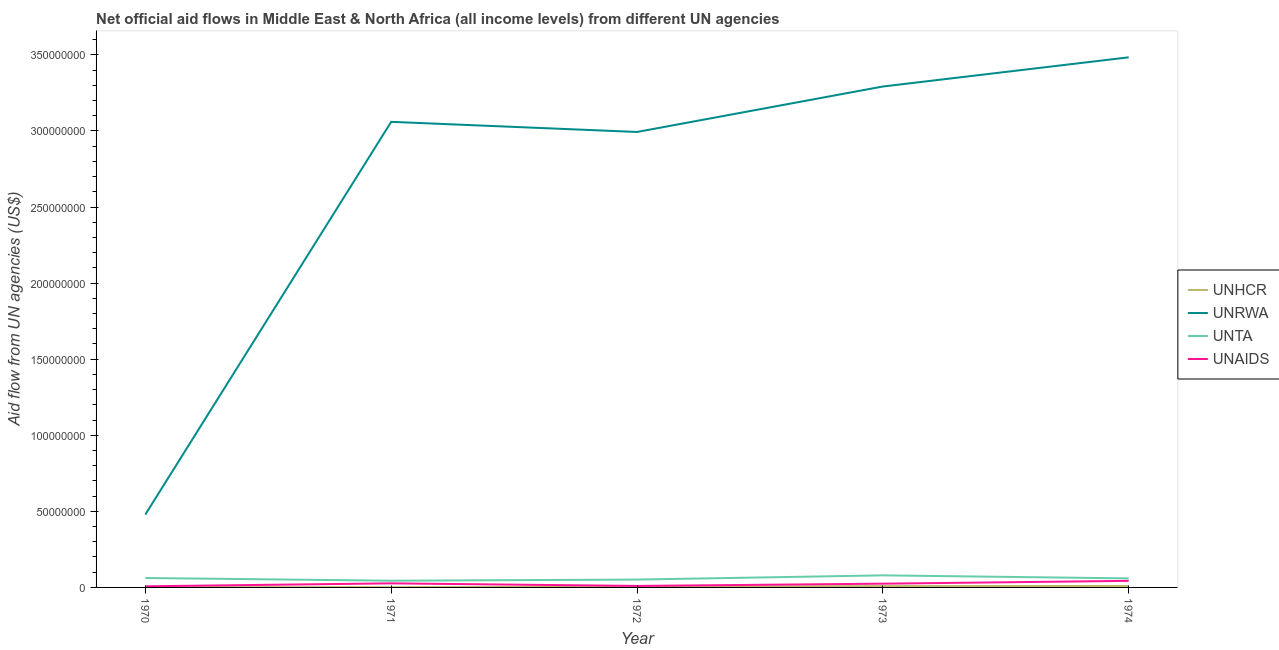How many different coloured lines are there?
Your answer should be compact. 4. What is the amount of aid given by unrwa in 1971?
Ensure brevity in your answer.  3.06e+08. Across all years, what is the maximum amount of aid given by unaids?
Offer a very short reply. 4.32e+06. Across all years, what is the minimum amount of aid given by unta?
Offer a terse response. 4.41e+06. In which year was the amount of aid given by unhcr maximum?
Offer a terse response. 1974. In which year was the amount of aid given by unrwa minimum?
Your answer should be compact. 1970. What is the total amount of aid given by unta in the graph?
Your response must be concise. 2.96e+07. What is the difference between the amount of aid given by unhcr in 1970 and that in 1973?
Make the answer very short. -7.10e+05. What is the difference between the amount of aid given by unhcr in 1973 and the amount of aid given by unta in 1972?
Offer a terse response. -4.28e+06. What is the average amount of aid given by unrwa per year?
Ensure brevity in your answer.  2.66e+08. In the year 1974, what is the difference between the amount of aid given by unta and amount of aid given by unhcr?
Keep it short and to the point. 4.97e+06. In how many years, is the amount of aid given by unaids greater than 250000000 US$?
Give a very brief answer. 0. What is the ratio of the amount of aid given by unrwa in 1973 to that in 1974?
Your response must be concise. 0.94. What is the difference between the highest and the second highest amount of aid given by unta?
Your response must be concise. 1.72e+06. What is the difference between the highest and the lowest amount of aid given by unrwa?
Your response must be concise. 3.00e+08. Is the sum of the amount of aid given by unta in 1970 and 1971 greater than the maximum amount of aid given by unaids across all years?
Ensure brevity in your answer.  Yes. Is the amount of aid given by unrwa strictly greater than the amount of aid given by unta over the years?
Provide a short and direct response. Yes. What is the difference between two consecutive major ticks on the Y-axis?
Offer a very short reply. 5.00e+07. Are the values on the major ticks of Y-axis written in scientific E-notation?
Give a very brief answer. No. Does the graph contain any zero values?
Your response must be concise. No. Where does the legend appear in the graph?
Ensure brevity in your answer.  Center right. How are the legend labels stacked?
Provide a succinct answer. Vertical. What is the title of the graph?
Your answer should be compact. Net official aid flows in Middle East & North Africa (all income levels) from different UN agencies. What is the label or title of the X-axis?
Make the answer very short. Year. What is the label or title of the Y-axis?
Give a very brief answer. Aid flow from UN agencies (US$). What is the Aid flow from UN agencies (US$) in UNHCR in 1970?
Make the answer very short. 1.70e+05. What is the Aid flow from UN agencies (US$) of UNRWA in 1970?
Provide a succinct answer. 4.79e+07. What is the Aid flow from UN agencies (US$) in UNTA in 1970?
Make the answer very short. 6.21e+06. What is the Aid flow from UN agencies (US$) in UNAIDS in 1970?
Make the answer very short. 7.40e+05. What is the Aid flow from UN agencies (US$) in UNHCR in 1971?
Your answer should be very brief. 1.40e+05. What is the Aid flow from UN agencies (US$) of UNRWA in 1971?
Offer a terse response. 3.06e+08. What is the Aid flow from UN agencies (US$) of UNTA in 1971?
Your response must be concise. 4.41e+06. What is the Aid flow from UN agencies (US$) in UNAIDS in 1971?
Provide a succinct answer. 2.68e+06. What is the Aid flow from UN agencies (US$) in UNRWA in 1972?
Offer a very short reply. 2.99e+08. What is the Aid flow from UN agencies (US$) of UNTA in 1972?
Offer a terse response. 5.16e+06. What is the Aid flow from UN agencies (US$) of UNAIDS in 1972?
Your response must be concise. 9.80e+05. What is the Aid flow from UN agencies (US$) in UNHCR in 1973?
Provide a succinct answer. 8.80e+05. What is the Aid flow from UN agencies (US$) in UNRWA in 1973?
Offer a very short reply. 3.29e+08. What is the Aid flow from UN agencies (US$) in UNTA in 1973?
Offer a very short reply. 7.93e+06. What is the Aid flow from UN agencies (US$) in UNAIDS in 1973?
Offer a very short reply. 2.47e+06. What is the Aid flow from UN agencies (US$) in UNHCR in 1974?
Keep it short and to the point. 9.70e+05. What is the Aid flow from UN agencies (US$) in UNRWA in 1974?
Your answer should be compact. 3.48e+08. What is the Aid flow from UN agencies (US$) of UNTA in 1974?
Ensure brevity in your answer.  5.94e+06. What is the Aid flow from UN agencies (US$) in UNAIDS in 1974?
Keep it short and to the point. 4.32e+06. Across all years, what is the maximum Aid flow from UN agencies (US$) of UNHCR?
Provide a short and direct response. 9.70e+05. Across all years, what is the maximum Aid flow from UN agencies (US$) in UNRWA?
Provide a short and direct response. 3.48e+08. Across all years, what is the maximum Aid flow from UN agencies (US$) of UNTA?
Your response must be concise. 7.93e+06. Across all years, what is the maximum Aid flow from UN agencies (US$) of UNAIDS?
Provide a short and direct response. 4.32e+06. Across all years, what is the minimum Aid flow from UN agencies (US$) in UNRWA?
Offer a very short reply. 4.79e+07. Across all years, what is the minimum Aid flow from UN agencies (US$) of UNTA?
Your response must be concise. 4.41e+06. Across all years, what is the minimum Aid flow from UN agencies (US$) in UNAIDS?
Your answer should be very brief. 7.40e+05. What is the total Aid flow from UN agencies (US$) in UNHCR in the graph?
Your answer should be very brief. 2.62e+06. What is the total Aid flow from UN agencies (US$) of UNRWA in the graph?
Ensure brevity in your answer.  1.33e+09. What is the total Aid flow from UN agencies (US$) in UNTA in the graph?
Offer a terse response. 2.96e+07. What is the total Aid flow from UN agencies (US$) of UNAIDS in the graph?
Ensure brevity in your answer.  1.12e+07. What is the difference between the Aid flow from UN agencies (US$) in UNRWA in 1970 and that in 1971?
Offer a very short reply. -2.58e+08. What is the difference between the Aid flow from UN agencies (US$) in UNTA in 1970 and that in 1971?
Ensure brevity in your answer.  1.80e+06. What is the difference between the Aid flow from UN agencies (US$) in UNAIDS in 1970 and that in 1971?
Provide a short and direct response. -1.94e+06. What is the difference between the Aid flow from UN agencies (US$) of UNHCR in 1970 and that in 1972?
Offer a terse response. -2.90e+05. What is the difference between the Aid flow from UN agencies (US$) in UNRWA in 1970 and that in 1972?
Ensure brevity in your answer.  -2.51e+08. What is the difference between the Aid flow from UN agencies (US$) in UNTA in 1970 and that in 1972?
Ensure brevity in your answer.  1.05e+06. What is the difference between the Aid flow from UN agencies (US$) in UNHCR in 1970 and that in 1973?
Make the answer very short. -7.10e+05. What is the difference between the Aid flow from UN agencies (US$) of UNRWA in 1970 and that in 1973?
Provide a short and direct response. -2.81e+08. What is the difference between the Aid flow from UN agencies (US$) of UNTA in 1970 and that in 1973?
Make the answer very short. -1.72e+06. What is the difference between the Aid flow from UN agencies (US$) of UNAIDS in 1970 and that in 1973?
Your response must be concise. -1.73e+06. What is the difference between the Aid flow from UN agencies (US$) of UNHCR in 1970 and that in 1974?
Offer a very short reply. -8.00e+05. What is the difference between the Aid flow from UN agencies (US$) of UNRWA in 1970 and that in 1974?
Offer a terse response. -3.00e+08. What is the difference between the Aid flow from UN agencies (US$) of UNTA in 1970 and that in 1974?
Ensure brevity in your answer.  2.70e+05. What is the difference between the Aid flow from UN agencies (US$) of UNAIDS in 1970 and that in 1974?
Your response must be concise. -3.58e+06. What is the difference between the Aid flow from UN agencies (US$) of UNHCR in 1971 and that in 1972?
Ensure brevity in your answer.  -3.20e+05. What is the difference between the Aid flow from UN agencies (US$) of UNRWA in 1971 and that in 1972?
Your response must be concise. 6.65e+06. What is the difference between the Aid flow from UN agencies (US$) of UNTA in 1971 and that in 1972?
Offer a very short reply. -7.50e+05. What is the difference between the Aid flow from UN agencies (US$) of UNAIDS in 1971 and that in 1972?
Ensure brevity in your answer.  1.70e+06. What is the difference between the Aid flow from UN agencies (US$) of UNHCR in 1971 and that in 1973?
Your answer should be very brief. -7.40e+05. What is the difference between the Aid flow from UN agencies (US$) of UNRWA in 1971 and that in 1973?
Provide a short and direct response. -2.32e+07. What is the difference between the Aid flow from UN agencies (US$) in UNTA in 1971 and that in 1973?
Your response must be concise. -3.52e+06. What is the difference between the Aid flow from UN agencies (US$) in UNHCR in 1971 and that in 1974?
Ensure brevity in your answer.  -8.30e+05. What is the difference between the Aid flow from UN agencies (US$) of UNRWA in 1971 and that in 1974?
Offer a terse response. -4.24e+07. What is the difference between the Aid flow from UN agencies (US$) in UNTA in 1971 and that in 1974?
Your answer should be compact. -1.53e+06. What is the difference between the Aid flow from UN agencies (US$) in UNAIDS in 1971 and that in 1974?
Offer a terse response. -1.64e+06. What is the difference between the Aid flow from UN agencies (US$) of UNHCR in 1972 and that in 1973?
Keep it short and to the point. -4.20e+05. What is the difference between the Aid flow from UN agencies (US$) in UNRWA in 1972 and that in 1973?
Provide a short and direct response. -2.99e+07. What is the difference between the Aid flow from UN agencies (US$) in UNTA in 1972 and that in 1973?
Give a very brief answer. -2.77e+06. What is the difference between the Aid flow from UN agencies (US$) in UNAIDS in 1972 and that in 1973?
Offer a very short reply. -1.49e+06. What is the difference between the Aid flow from UN agencies (US$) in UNHCR in 1972 and that in 1974?
Provide a short and direct response. -5.10e+05. What is the difference between the Aid flow from UN agencies (US$) in UNRWA in 1972 and that in 1974?
Provide a short and direct response. -4.91e+07. What is the difference between the Aid flow from UN agencies (US$) in UNTA in 1972 and that in 1974?
Give a very brief answer. -7.80e+05. What is the difference between the Aid flow from UN agencies (US$) of UNAIDS in 1972 and that in 1974?
Ensure brevity in your answer.  -3.34e+06. What is the difference between the Aid flow from UN agencies (US$) of UNRWA in 1973 and that in 1974?
Give a very brief answer. -1.92e+07. What is the difference between the Aid flow from UN agencies (US$) of UNTA in 1973 and that in 1974?
Your answer should be very brief. 1.99e+06. What is the difference between the Aid flow from UN agencies (US$) in UNAIDS in 1973 and that in 1974?
Keep it short and to the point. -1.85e+06. What is the difference between the Aid flow from UN agencies (US$) of UNHCR in 1970 and the Aid flow from UN agencies (US$) of UNRWA in 1971?
Offer a terse response. -3.06e+08. What is the difference between the Aid flow from UN agencies (US$) of UNHCR in 1970 and the Aid flow from UN agencies (US$) of UNTA in 1971?
Your response must be concise. -4.24e+06. What is the difference between the Aid flow from UN agencies (US$) of UNHCR in 1970 and the Aid flow from UN agencies (US$) of UNAIDS in 1971?
Your answer should be very brief. -2.51e+06. What is the difference between the Aid flow from UN agencies (US$) in UNRWA in 1970 and the Aid flow from UN agencies (US$) in UNTA in 1971?
Ensure brevity in your answer.  4.35e+07. What is the difference between the Aid flow from UN agencies (US$) in UNRWA in 1970 and the Aid flow from UN agencies (US$) in UNAIDS in 1971?
Ensure brevity in your answer.  4.52e+07. What is the difference between the Aid flow from UN agencies (US$) in UNTA in 1970 and the Aid flow from UN agencies (US$) in UNAIDS in 1971?
Offer a very short reply. 3.53e+06. What is the difference between the Aid flow from UN agencies (US$) in UNHCR in 1970 and the Aid flow from UN agencies (US$) in UNRWA in 1972?
Make the answer very short. -2.99e+08. What is the difference between the Aid flow from UN agencies (US$) in UNHCR in 1970 and the Aid flow from UN agencies (US$) in UNTA in 1972?
Keep it short and to the point. -4.99e+06. What is the difference between the Aid flow from UN agencies (US$) in UNHCR in 1970 and the Aid flow from UN agencies (US$) in UNAIDS in 1972?
Your answer should be compact. -8.10e+05. What is the difference between the Aid flow from UN agencies (US$) in UNRWA in 1970 and the Aid flow from UN agencies (US$) in UNTA in 1972?
Offer a terse response. 4.28e+07. What is the difference between the Aid flow from UN agencies (US$) of UNRWA in 1970 and the Aid flow from UN agencies (US$) of UNAIDS in 1972?
Provide a succinct answer. 4.70e+07. What is the difference between the Aid flow from UN agencies (US$) of UNTA in 1970 and the Aid flow from UN agencies (US$) of UNAIDS in 1972?
Ensure brevity in your answer.  5.23e+06. What is the difference between the Aid flow from UN agencies (US$) in UNHCR in 1970 and the Aid flow from UN agencies (US$) in UNRWA in 1973?
Offer a very short reply. -3.29e+08. What is the difference between the Aid flow from UN agencies (US$) in UNHCR in 1970 and the Aid flow from UN agencies (US$) in UNTA in 1973?
Your answer should be very brief. -7.76e+06. What is the difference between the Aid flow from UN agencies (US$) in UNHCR in 1970 and the Aid flow from UN agencies (US$) in UNAIDS in 1973?
Offer a very short reply. -2.30e+06. What is the difference between the Aid flow from UN agencies (US$) in UNRWA in 1970 and the Aid flow from UN agencies (US$) in UNTA in 1973?
Ensure brevity in your answer.  4.00e+07. What is the difference between the Aid flow from UN agencies (US$) of UNRWA in 1970 and the Aid flow from UN agencies (US$) of UNAIDS in 1973?
Ensure brevity in your answer.  4.55e+07. What is the difference between the Aid flow from UN agencies (US$) of UNTA in 1970 and the Aid flow from UN agencies (US$) of UNAIDS in 1973?
Offer a very short reply. 3.74e+06. What is the difference between the Aid flow from UN agencies (US$) of UNHCR in 1970 and the Aid flow from UN agencies (US$) of UNRWA in 1974?
Offer a very short reply. -3.48e+08. What is the difference between the Aid flow from UN agencies (US$) of UNHCR in 1970 and the Aid flow from UN agencies (US$) of UNTA in 1974?
Make the answer very short. -5.77e+06. What is the difference between the Aid flow from UN agencies (US$) of UNHCR in 1970 and the Aid flow from UN agencies (US$) of UNAIDS in 1974?
Your answer should be very brief. -4.15e+06. What is the difference between the Aid flow from UN agencies (US$) in UNRWA in 1970 and the Aid flow from UN agencies (US$) in UNTA in 1974?
Make the answer very short. 4.20e+07. What is the difference between the Aid flow from UN agencies (US$) in UNRWA in 1970 and the Aid flow from UN agencies (US$) in UNAIDS in 1974?
Your response must be concise. 4.36e+07. What is the difference between the Aid flow from UN agencies (US$) of UNTA in 1970 and the Aid flow from UN agencies (US$) of UNAIDS in 1974?
Your answer should be very brief. 1.89e+06. What is the difference between the Aid flow from UN agencies (US$) of UNHCR in 1971 and the Aid flow from UN agencies (US$) of UNRWA in 1972?
Provide a succinct answer. -2.99e+08. What is the difference between the Aid flow from UN agencies (US$) in UNHCR in 1971 and the Aid flow from UN agencies (US$) in UNTA in 1972?
Keep it short and to the point. -5.02e+06. What is the difference between the Aid flow from UN agencies (US$) of UNHCR in 1971 and the Aid flow from UN agencies (US$) of UNAIDS in 1972?
Make the answer very short. -8.40e+05. What is the difference between the Aid flow from UN agencies (US$) in UNRWA in 1971 and the Aid flow from UN agencies (US$) in UNTA in 1972?
Offer a very short reply. 3.01e+08. What is the difference between the Aid flow from UN agencies (US$) of UNRWA in 1971 and the Aid flow from UN agencies (US$) of UNAIDS in 1972?
Offer a terse response. 3.05e+08. What is the difference between the Aid flow from UN agencies (US$) of UNTA in 1971 and the Aid flow from UN agencies (US$) of UNAIDS in 1972?
Give a very brief answer. 3.43e+06. What is the difference between the Aid flow from UN agencies (US$) in UNHCR in 1971 and the Aid flow from UN agencies (US$) in UNRWA in 1973?
Provide a succinct answer. -3.29e+08. What is the difference between the Aid flow from UN agencies (US$) of UNHCR in 1971 and the Aid flow from UN agencies (US$) of UNTA in 1973?
Make the answer very short. -7.79e+06. What is the difference between the Aid flow from UN agencies (US$) of UNHCR in 1971 and the Aid flow from UN agencies (US$) of UNAIDS in 1973?
Make the answer very short. -2.33e+06. What is the difference between the Aid flow from UN agencies (US$) of UNRWA in 1971 and the Aid flow from UN agencies (US$) of UNTA in 1973?
Offer a very short reply. 2.98e+08. What is the difference between the Aid flow from UN agencies (US$) in UNRWA in 1971 and the Aid flow from UN agencies (US$) in UNAIDS in 1973?
Your answer should be compact. 3.04e+08. What is the difference between the Aid flow from UN agencies (US$) in UNTA in 1971 and the Aid flow from UN agencies (US$) in UNAIDS in 1973?
Give a very brief answer. 1.94e+06. What is the difference between the Aid flow from UN agencies (US$) in UNHCR in 1971 and the Aid flow from UN agencies (US$) in UNRWA in 1974?
Offer a very short reply. -3.48e+08. What is the difference between the Aid flow from UN agencies (US$) of UNHCR in 1971 and the Aid flow from UN agencies (US$) of UNTA in 1974?
Your response must be concise. -5.80e+06. What is the difference between the Aid flow from UN agencies (US$) in UNHCR in 1971 and the Aid flow from UN agencies (US$) in UNAIDS in 1974?
Give a very brief answer. -4.18e+06. What is the difference between the Aid flow from UN agencies (US$) of UNRWA in 1971 and the Aid flow from UN agencies (US$) of UNTA in 1974?
Ensure brevity in your answer.  3.00e+08. What is the difference between the Aid flow from UN agencies (US$) in UNRWA in 1971 and the Aid flow from UN agencies (US$) in UNAIDS in 1974?
Offer a very short reply. 3.02e+08. What is the difference between the Aid flow from UN agencies (US$) of UNHCR in 1972 and the Aid flow from UN agencies (US$) of UNRWA in 1973?
Your answer should be very brief. -3.29e+08. What is the difference between the Aid flow from UN agencies (US$) of UNHCR in 1972 and the Aid flow from UN agencies (US$) of UNTA in 1973?
Your answer should be very brief. -7.47e+06. What is the difference between the Aid flow from UN agencies (US$) in UNHCR in 1972 and the Aid flow from UN agencies (US$) in UNAIDS in 1973?
Provide a succinct answer. -2.01e+06. What is the difference between the Aid flow from UN agencies (US$) in UNRWA in 1972 and the Aid flow from UN agencies (US$) in UNTA in 1973?
Keep it short and to the point. 2.91e+08. What is the difference between the Aid flow from UN agencies (US$) of UNRWA in 1972 and the Aid flow from UN agencies (US$) of UNAIDS in 1973?
Your response must be concise. 2.97e+08. What is the difference between the Aid flow from UN agencies (US$) of UNTA in 1972 and the Aid flow from UN agencies (US$) of UNAIDS in 1973?
Keep it short and to the point. 2.69e+06. What is the difference between the Aid flow from UN agencies (US$) in UNHCR in 1972 and the Aid flow from UN agencies (US$) in UNRWA in 1974?
Give a very brief answer. -3.48e+08. What is the difference between the Aid flow from UN agencies (US$) of UNHCR in 1972 and the Aid flow from UN agencies (US$) of UNTA in 1974?
Provide a succinct answer. -5.48e+06. What is the difference between the Aid flow from UN agencies (US$) in UNHCR in 1972 and the Aid flow from UN agencies (US$) in UNAIDS in 1974?
Your answer should be very brief. -3.86e+06. What is the difference between the Aid flow from UN agencies (US$) of UNRWA in 1972 and the Aid flow from UN agencies (US$) of UNTA in 1974?
Give a very brief answer. 2.93e+08. What is the difference between the Aid flow from UN agencies (US$) in UNRWA in 1972 and the Aid flow from UN agencies (US$) in UNAIDS in 1974?
Offer a terse response. 2.95e+08. What is the difference between the Aid flow from UN agencies (US$) of UNTA in 1972 and the Aid flow from UN agencies (US$) of UNAIDS in 1974?
Make the answer very short. 8.40e+05. What is the difference between the Aid flow from UN agencies (US$) of UNHCR in 1973 and the Aid flow from UN agencies (US$) of UNRWA in 1974?
Keep it short and to the point. -3.48e+08. What is the difference between the Aid flow from UN agencies (US$) in UNHCR in 1973 and the Aid flow from UN agencies (US$) in UNTA in 1974?
Give a very brief answer. -5.06e+06. What is the difference between the Aid flow from UN agencies (US$) in UNHCR in 1973 and the Aid flow from UN agencies (US$) in UNAIDS in 1974?
Keep it short and to the point. -3.44e+06. What is the difference between the Aid flow from UN agencies (US$) of UNRWA in 1973 and the Aid flow from UN agencies (US$) of UNTA in 1974?
Ensure brevity in your answer.  3.23e+08. What is the difference between the Aid flow from UN agencies (US$) in UNRWA in 1973 and the Aid flow from UN agencies (US$) in UNAIDS in 1974?
Make the answer very short. 3.25e+08. What is the difference between the Aid flow from UN agencies (US$) of UNTA in 1973 and the Aid flow from UN agencies (US$) of UNAIDS in 1974?
Your answer should be very brief. 3.61e+06. What is the average Aid flow from UN agencies (US$) in UNHCR per year?
Your answer should be compact. 5.24e+05. What is the average Aid flow from UN agencies (US$) in UNRWA per year?
Keep it short and to the point. 2.66e+08. What is the average Aid flow from UN agencies (US$) in UNTA per year?
Your response must be concise. 5.93e+06. What is the average Aid flow from UN agencies (US$) of UNAIDS per year?
Provide a succinct answer. 2.24e+06. In the year 1970, what is the difference between the Aid flow from UN agencies (US$) in UNHCR and Aid flow from UN agencies (US$) in UNRWA?
Provide a short and direct response. -4.78e+07. In the year 1970, what is the difference between the Aid flow from UN agencies (US$) of UNHCR and Aid flow from UN agencies (US$) of UNTA?
Make the answer very short. -6.04e+06. In the year 1970, what is the difference between the Aid flow from UN agencies (US$) of UNHCR and Aid flow from UN agencies (US$) of UNAIDS?
Provide a short and direct response. -5.70e+05. In the year 1970, what is the difference between the Aid flow from UN agencies (US$) of UNRWA and Aid flow from UN agencies (US$) of UNTA?
Keep it short and to the point. 4.17e+07. In the year 1970, what is the difference between the Aid flow from UN agencies (US$) in UNRWA and Aid flow from UN agencies (US$) in UNAIDS?
Make the answer very short. 4.72e+07. In the year 1970, what is the difference between the Aid flow from UN agencies (US$) in UNTA and Aid flow from UN agencies (US$) in UNAIDS?
Give a very brief answer. 5.47e+06. In the year 1971, what is the difference between the Aid flow from UN agencies (US$) in UNHCR and Aid flow from UN agencies (US$) in UNRWA?
Ensure brevity in your answer.  -3.06e+08. In the year 1971, what is the difference between the Aid flow from UN agencies (US$) of UNHCR and Aid flow from UN agencies (US$) of UNTA?
Offer a terse response. -4.27e+06. In the year 1971, what is the difference between the Aid flow from UN agencies (US$) of UNHCR and Aid flow from UN agencies (US$) of UNAIDS?
Ensure brevity in your answer.  -2.54e+06. In the year 1971, what is the difference between the Aid flow from UN agencies (US$) of UNRWA and Aid flow from UN agencies (US$) of UNTA?
Make the answer very short. 3.02e+08. In the year 1971, what is the difference between the Aid flow from UN agencies (US$) of UNRWA and Aid flow from UN agencies (US$) of UNAIDS?
Your response must be concise. 3.03e+08. In the year 1971, what is the difference between the Aid flow from UN agencies (US$) of UNTA and Aid flow from UN agencies (US$) of UNAIDS?
Your answer should be compact. 1.73e+06. In the year 1972, what is the difference between the Aid flow from UN agencies (US$) of UNHCR and Aid flow from UN agencies (US$) of UNRWA?
Offer a very short reply. -2.99e+08. In the year 1972, what is the difference between the Aid flow from UN agencies (US$) of UNHCR and Aid flow from UN agencies (US$) of UNTA?
Ensure brevity in your answer.  -4.70e+06. In the year 1972, what is the difference between the Aid flow from UN agencies (US$) in UNHCR and Aid flow from UN agencies (US$) in UNAIDS?
Your answer should be compact. -5.20e+05. In the year 1972, what is the difference between the Aid flow from UN agencies (US$) in UNRWA and Aid flow from UN agencies (US$) in UNTA?
Ensure brevity in your answer.  2.94e+08. In the year 1972, what is the difference between the Aid flow from UN agencies (US$) in UNRWA and Aid flow from UN agencies (US$) in UNAIDS?
Your answer should be compact. 2.98e+08. In the year 1972, what is the difference between the Aid flow from UN agencies (US$) of UNTA and Aid flow from UN agencies (US$) of UNAIDS?
Provide a short and direct response. 4.18e+06. In the year 1973, what is the difference between the Aid flow from UN agencies (US$) in UNHCR and Aid flow from UN agencies (US$) in UNRWA?
Provide a short and direct response. -3.28e+08. In the year 1973, what is the difference between the Aid flow from UN agencies (US$) of UNHCR and Aid flow from UN agencies (US$) of UNTA?
Your answer should be very brief. -7.05e+06. In the year 1973, what is the difference between the Aid flow from UN agencies (US$) in UNHCR and Aid flow from UN agencies (US$) in UNAIDS?
Offer a terse response. -1.59e+06. In the year 1973, what is the difference between the Aid flow from UN agencies (US$) in UNRWA and Aid flow from UN agencies (US$) in UNTA?
Offer a very short reply. 3.21e+08. In the year 1973, what is the difference between the Aid flow from UN agencies (US$) in UNRWA and Aid flow from UN agencies (US$) in UNAIDS?
Provide a short and direct response. 3.27e+08. In the year 1973, what is the difference between the Aid flow from UN agencies (US$) of UNTA and Aid flow from UN agencies (US$) of UNAIDS?
Provide a succinct answer. 5.46e+06. In the year 1974, what is the difference between the Aid flow from UN agencies (US$) of UNHCR and Aid flow from UN agencies (US$) of UNRWA?
Give a very brief answer. -3.47e+08. In the year 1974, what is the difference between the Aid flow from UN agencies (US$) of UNHCR and Aid flow from UN agencies (US$) of UNTA?
Your answer should be compact. -4.97e+06. In the year 1974, what is the difference between the Aid flow from UN agencies (US$) of UNHCR and Aid flow from UN agencies (US$) of UNAIDS?
Ensure brevity in your answer.  -3.35e+06. In the year 1974, what is the difference between the Aid flow from UN agencies (US$) in UNRWA and Aid flow from UN agencies (US$) in UNTA?
Your answer should be very brief. 3.42e+08. In the year 1974, what is the difference between the Aid flow from UN agencies (US$) of UNRWA and Aid flow from UN agencies (US$) of UNAIDS?
Offer a terse response. 3.44e+08. In the year 1974, what is the difference between the Aid flow from UN agencies (US$) of UNTA and Aid flow from UN agencies (US$) of UNAIDS?
Your answer should be very brief. 1.62e+06. What is the ratio of the Aid flow from UN agencies (US$) of UNHCR in 1970 to that in 1971?
Ensure brevity in your answer.  1.21. What is the ratio of the Aid flow from UN agencies (US$) of UNRWA in 1970 to that in 1971?
Your answer should be compact. 0.16. What is the ratio of the Aid flow from UN agencies (US$) in UNTA in 1970 to that in 1971?
Offer a terse response. 1.41. What is the ratio of the Aid flow from UN agencies (US$) of UNAIDS in 1970 to that in 1971?
Offer a terse response. 0.28. What is the ratio of the Aid flow from UN agencies (US$) in UNHCR in 1970 to that in 1972?
Offer a very short reply. 0.37. What is the ratio of the Aid flow from UN agencies (US$) in UNRWA in 1970 to that in 1972?
Offer a terse response. 0.16. What is the ratio of the Aid flow from UN agencies (US$) in UNTA in 1970 to that in 1972?
Provide a succinct answer. 1.2. What is the ratio of the Aid flow from UN agencies (US$) in UNAIDS in 1970 to that in 1972?
Make the answer very short. 0.76. What is the ratio of the Aid flow from UN agencies (US$) of UNHCR in 1970 to that in 1973?
Your answer should be very brief. 0.19. What is the ratio of the Aid flow from UN agencies (US$) of UNRWA in 1970 to that in 1973?
Offer a very short reply. 0.15. What is the ratio of the Aid flow from UN agencies (US$) of UNTA in 1970 to that in 1973?
Provide a short and direct response. 0.78. What is the ratio of the Aid flow from UN agencies (US$) of UNAIDS in 1970 to that in 1973?
Your response must be concise. 0.3. What is the ratio of the Aid flow from UN agencies (US$) in UNHCR in 1970 to that in 1974?
Provide a short and direct response. 0.18. What is the ratio of the Aid flow from UN agencies (US$) of UNRWA in 1970 to that in 1974?
Provide a succinct answer. 0.14. What is the ratio of the Aid flow from UN agencies (US$) of UNTA in 1970 to that in 1974?
Offer a very short reply. 1.05. What is the ratio of the Aid flow from UN agencies (US$) in UNAIDS in 1970 to that in 1974?
Offer a very short reply. 0.17. What is the ratio of the Aid flow from UN agencies (US$) of UNHCR in 1971 to that in 1972?
Offer a very short reply. 0.3. What is the ratio of the Aid flow from UN agencies (US$) in UNRWA in 1971 to that in 1972?
Offer a very short reply. 1.02. What is the ratio of the Aid flow from UN agencies (US$) in UNTA in 1971 to that in 1972?
Keep it short and to the point. 0.85. What is the ratio of the Aid flow from UN agencies (US$) of UNAIDS in 1971 to that in 1972?
Offer a very short reply. 2.73. What is the ratio of the Aid flow from UN agencies (US$) of UNHCR in 1971 to that in 1973?
Offer a terse response. 0.16. What is the ratio of the Aid flow from UN agencies (US$) of UNRWA in 1971 to that in 1973?
Offer a terse response. 0.93. What is the ratio of the Aid flow from UN agencies (US$) in UNTA in 1971 to that in 1973?
Keep it short and to the point. 0.56. What is the ratio of the Aid flow from UN agencies (US$) in UNAIDS in 1971 to that in 1973?
Your answer should be very brief. 1.08. What is the ratio of the Aid flow from UN agencies (US$) in UNHCR in 1971 to that in 1974?
Offer a terse response. 0.14. What is the ratio of the Aid flow from UN agencies (US$) in UNRWA in 1971 to that in 1974?
Offer a terse response. 0.88. What is the ratio of the Aid flow from UN agencies (US$) of UNTA in 1971 to that in 1974?
Ensure brevity in your answer.  0.74. What is the ratio of the Aid flow from UN agencies (US$) in UNAIDS in 1971 to that in 1974?
Give a very brief answer. 0.62. What is the ratio of the Aid flow from UN agencies (US$) in UNHCR in 1972 to that in 1973?
Your answer should be compact. 0.52. What is the ratio of the Aid flow from UN agencies (US$) of UNRWA in 1972 to that in 1973?
Offer a very short reply. 0.91. What is the ratio of the Aid flow from UN agencies (US$) of UNTA in 1972 to that in 1973?
Ensure brevity in your answer.  0.65. What is the ratio of the Aid flow from UN agencies (US$) of UNAIDS in 1972 to that in 1973?
Your response must be concise. 0.4. What is the ratio of the Aid flow from UN agencies (US$) in UNHCR in 1972 to that in 1974?
Make the answer very short. 0.47. What is the ratio of the Aid flow from UN agencies (US$) of UNRWA in 1972 to that in 1974?
Ensure brevity in your answer.  0.86. What is the ratio of the Aid flow from UN agencies (US$) of UNTA in 1972 to that in 1974?
Make the answer very short. 0.87. What is the ratio of the Aid flow from UN agencies (US$) of UNAIDS in 1972 to that in 1974?
Keep it short and to the point. 0.23. What is the ratio of the Aid flow from UN agencies (US$) in UNHCR in 1973 to that in 1974?
Your answer should be compact. 0.91. What is the ratio of the Aid flow from UN agencies (US$) of UNRWA in 1973 to that in 1974?
Make the answer very short. 0.94. What is the ratio of the Aid flow from UN agencies (US$) of UNTA in 1973 to that in 1974?
Your answer should be very brief. 1.33. What is the ratio of the Aid flow from UN agencies (US$) of UNAIDS in 1973 to that in 1974?
Your answer should be very brief. 0.57. What is the difference between the highest and the second highest Aid flow from UN agencies (US$) in UNHCR?
Your response must be concise. 9.00e+04. What is the difference between the highest and the second highest Aid flow from UN agencies (US$) of UNRWA?
Provide a succinct answer. 1.92e+07. What is the difference between the highest and the second highest Aid flow from UN agencies (US$) of UNTA?
Your response must be concise. 1.72e+06. What is the difference between the highest and the second highest Aid flow from UN agencies (US$) in UNAIDS?
Your answer should be compact. 1.64e+06. What is the difference between the highest and the lowest Aid flow from UN agencies (US$) of UNHCR?
Give a very brief answer. 8.30e+05. What is the difference between the highest and the lowest Aid flow from UN agencies (US$) of UNRWA?
Offer a terse response. 3.00e+08. What is the difference between the highest and the lowest Aid flow from UN agencies (US$) in UNTA?
Your answer should be compact. 3.52e+06. What is the difference between the highest and the lowest Aid flow from UN agencies (US$) in UNAIDS?
Offer a terse response. 3.58e+06. 